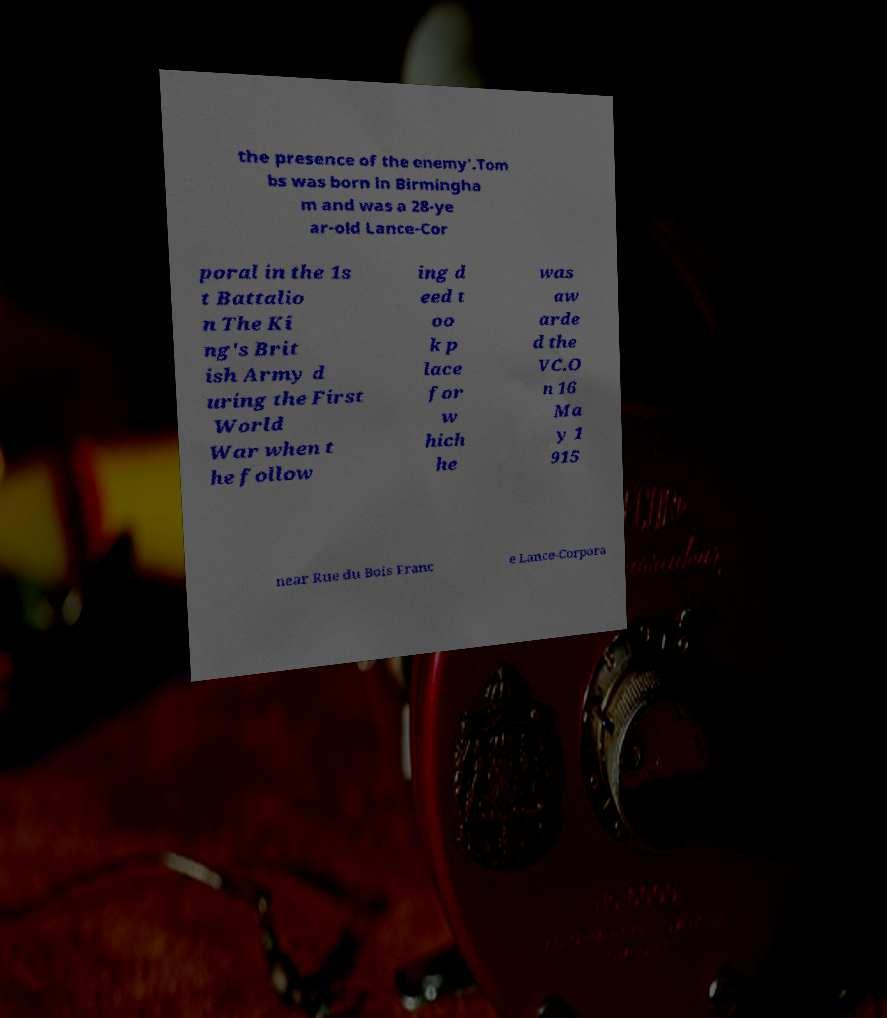What messages or text are displayed in this image? I need them in a readable, typed format. the presence of the enemy’.Tom bs was born in Birmingha m and was a 28-ye ar-old Lance-Cor poral in the 1s t Battalio n The Ki ng's Brit ish Army d uring the First World War when t he follow ing d eed t oo k p lace for w hich he was aw arde d the VC.O n 16 Ma y 1 915 near Rue du Bois Franc e Lance-Corpora 